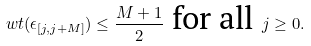Convert formula to latex. <formula><loc_0><loc_0><loc_500><loc_500>\ w t ( \epsilon _ { [ j , j + M ] } ) \leq \frac { M + 1 } { 2 } \text { for all } j \geq 0 .</formula> 